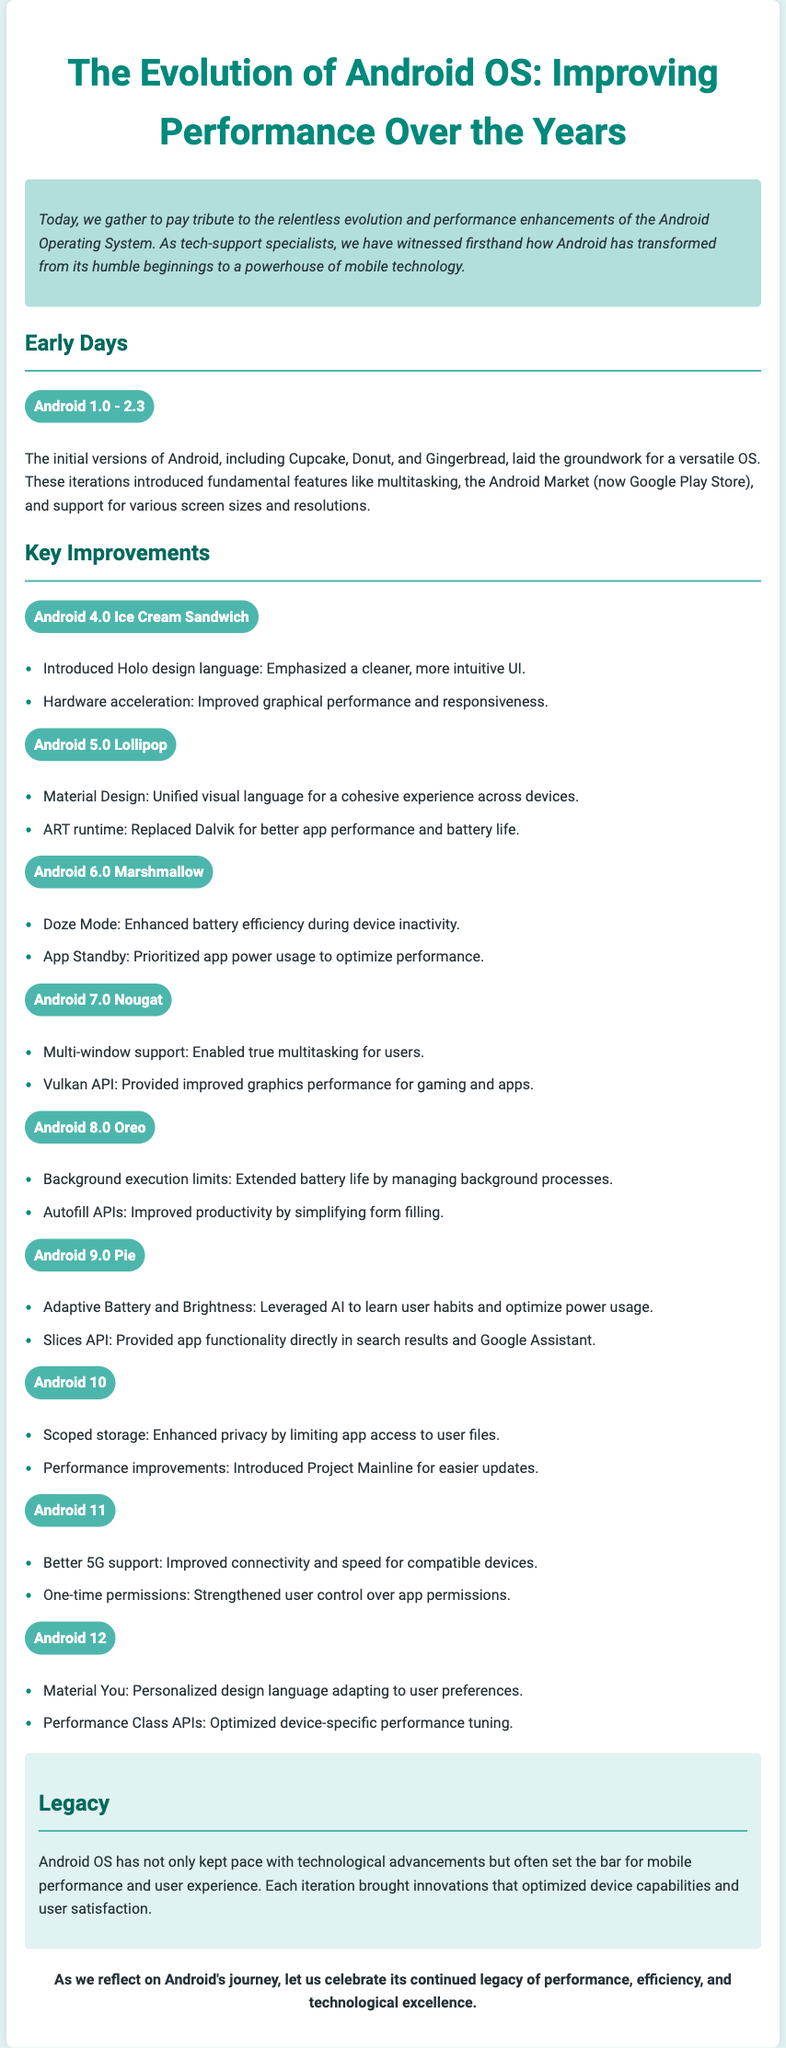What is the title of the document? The title is given as the main heading of the document at the top.
Answer: The Evolution of Android OS: Improving Performance Over the Years Which Android version introduced Doze Mode? Doze Mode is specifically mentioned under the features of one of the Android versions listed in the Key Improvements section.
Answer: Android 6.0 Marshmallow What design language was introduced in Android 4.0? The document specifies the key feature related to UI design for this version.
Answer: Holo design language What significant runtime was introduced in Android 5.0? This detail about the runtime is clearly stated as a key improvement for this version of Android OS.
Answer: ART runtime Which version improved background execution limits? This is a notable feature mentioned in relation to one of the Android versions under Key Improvements.
Answer: Android 8.0 Oreo How many key improvements are listed for Android 9.0? The number of key improvements is determined by counting the items listed under that version in the document.
Answer: 2 What feature does the Slices API provide? The document states the functionality provided by the Slices API in relation to user interactions.
Answer: App functionality directly in search results Which Android version is associated with 'Material You'? This term is directly linked to a specific version mentioned in the Key Improvements section.
Answer: Android 12 What is the essence of the closing statement? The essence is summarized in the final paragraph of the document, reflecting on the legacy of Android OS.
Answer: Celebrate its continued legacy of performance, efficiency, and technological excellence 